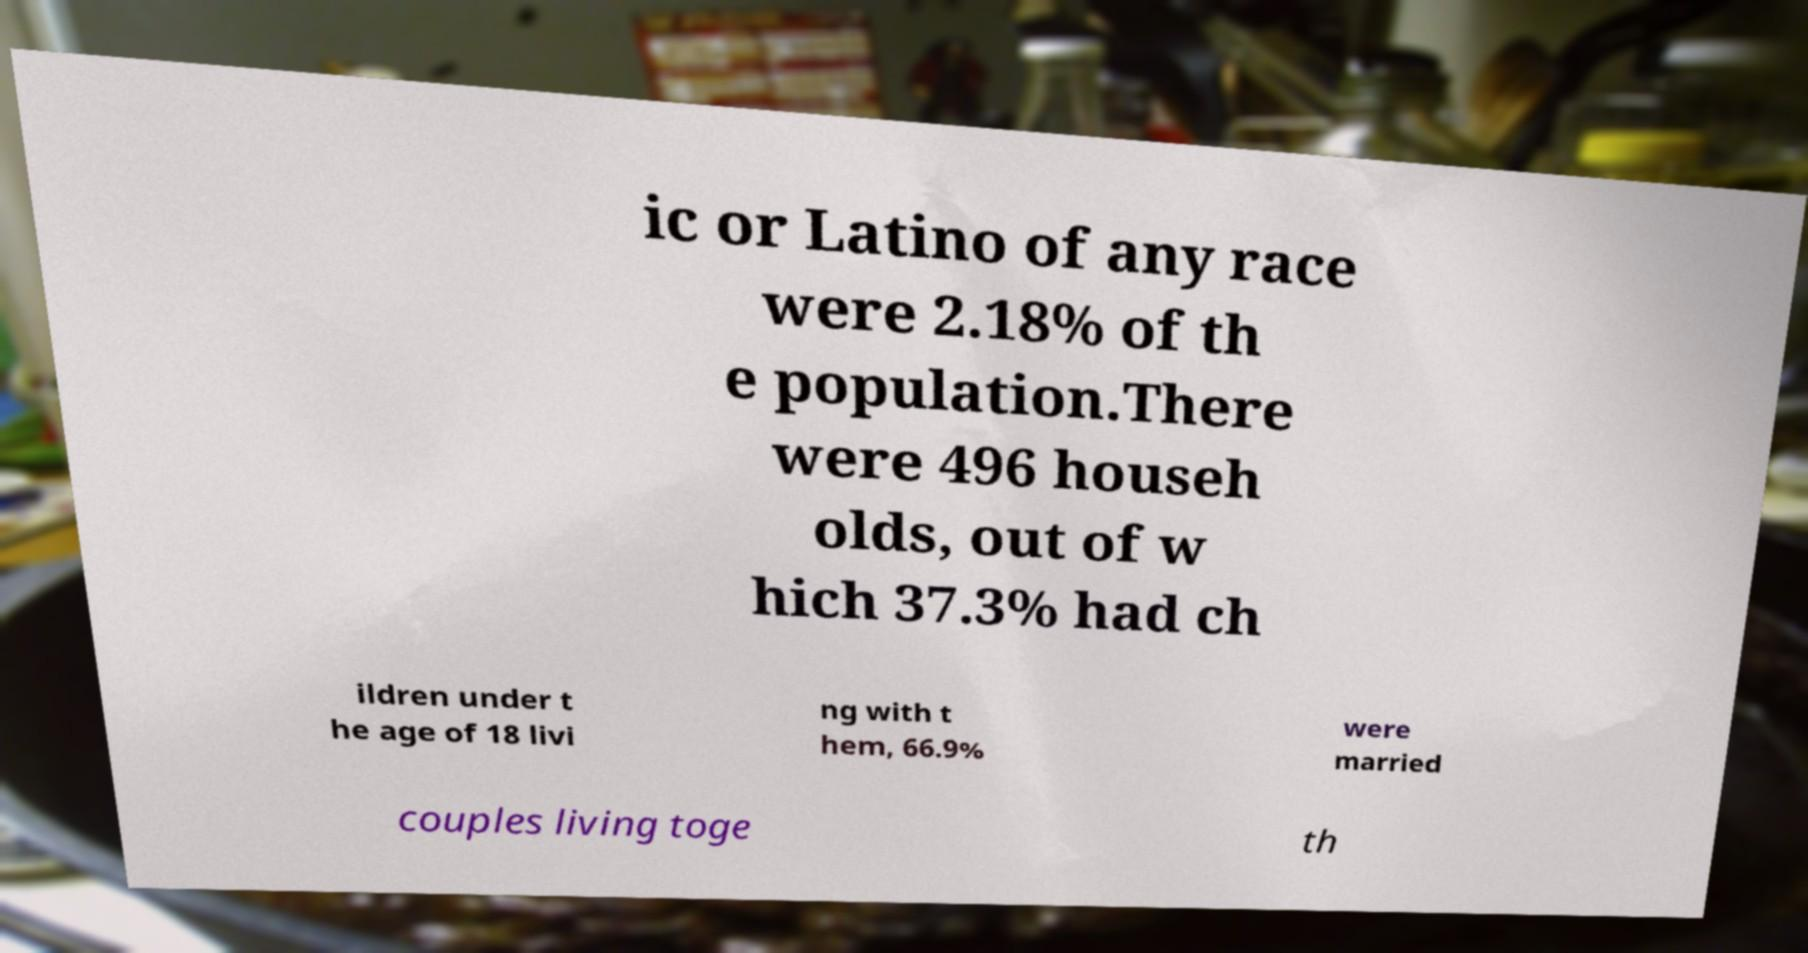Please identify and transcribe the text found in this image. ic or Latino of any race were 2.18% of th e population.There were 496 househ olds, out of w hich 37.3% had ch ildren under t he age of 18 livi ng with t hem, 66.9% were married couples living toge th 